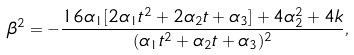Convert formula to latex. <formula><loc_0><loc_0><loc_500><loc_500>\beta ^ { 2 } = - \frac { 1 6 \alpha _ { 1 } [ 2 \alpha _ { 1 } t ^ { 2 } + 2 \alpha _ { 2 } t + \alpha _ { 3 } ] + 4 \alpha _ { 2 } ^ { 2 } + 4 k } { ( \alpha _ { 1 } t ^ { 2 } + \alpha _ { 2 } t + \alpha _ { 3 } ) ^ { 2 } } ,</formula> 